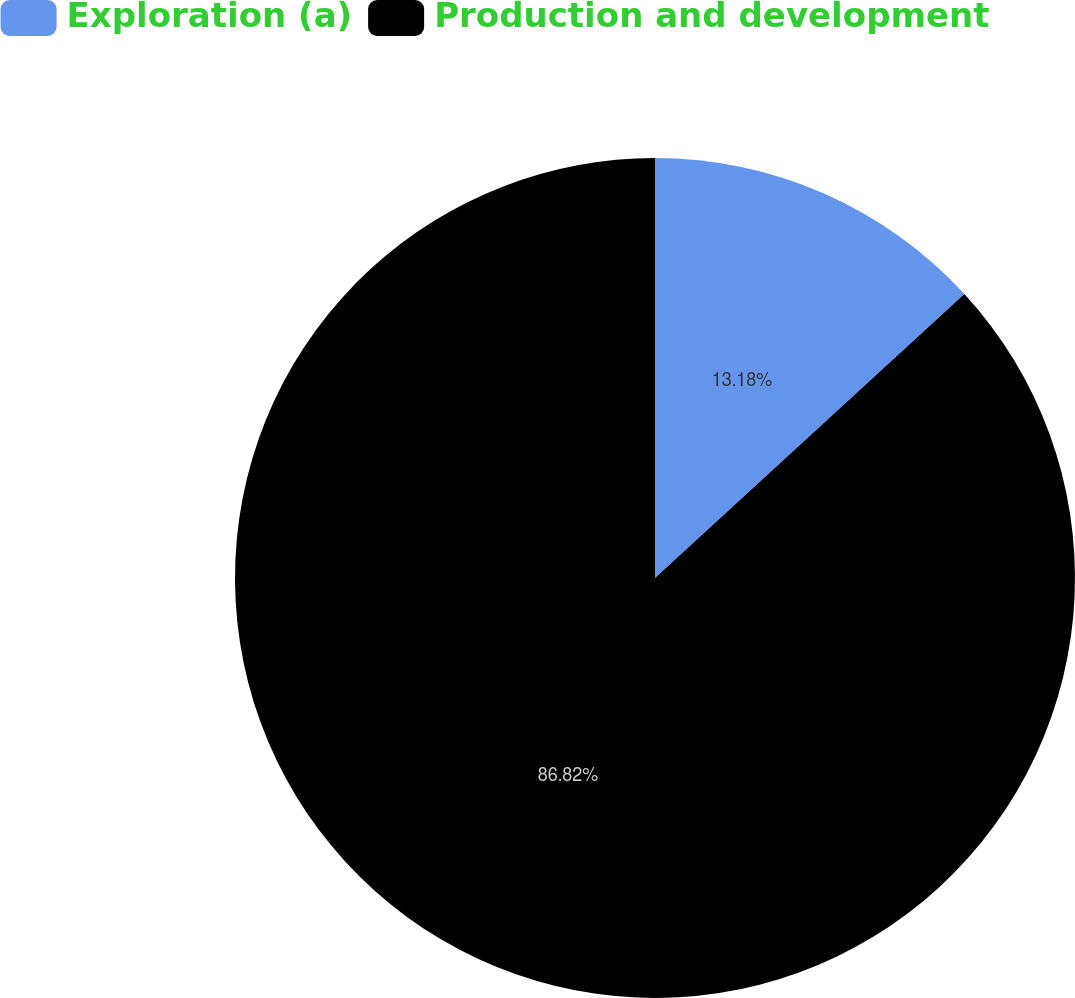Convert chart. <chart><loc_0><loc_0><loc_500><loc_500><pie_chart><fcel>Exploration (a)<fcel>Production and development<nl><fcel>13.18%<fcel>86.82%<nl></chart> 